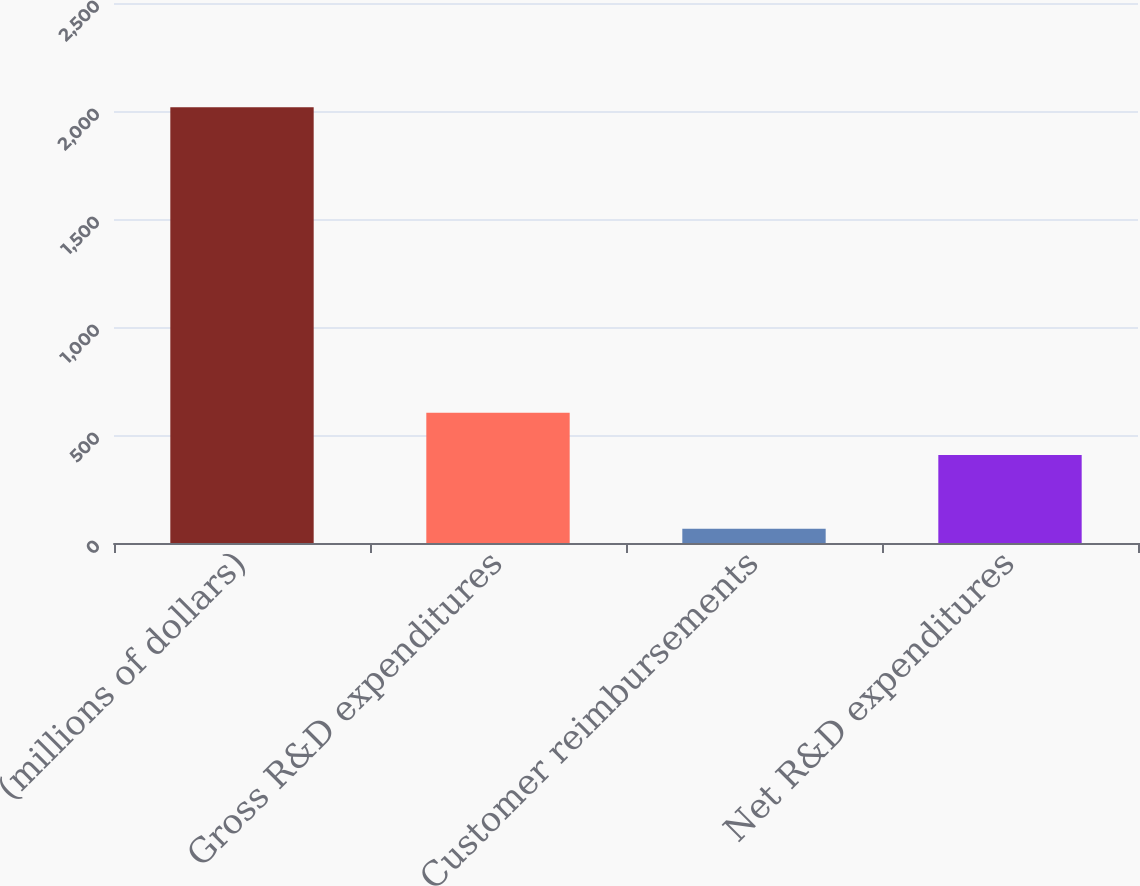Convert chart. <chart><loc_0><loc_0><loc_500><loc_500><bar_chart><fcel>(millions of dollars)<fcel>Gross R&D expenditures<fcel>Customer reimbursements<fcel>Net R&D expenditures<nl><fcel>2017<fcel>602.64<fcel>65.6<fcel>407.5<nl></chart> 